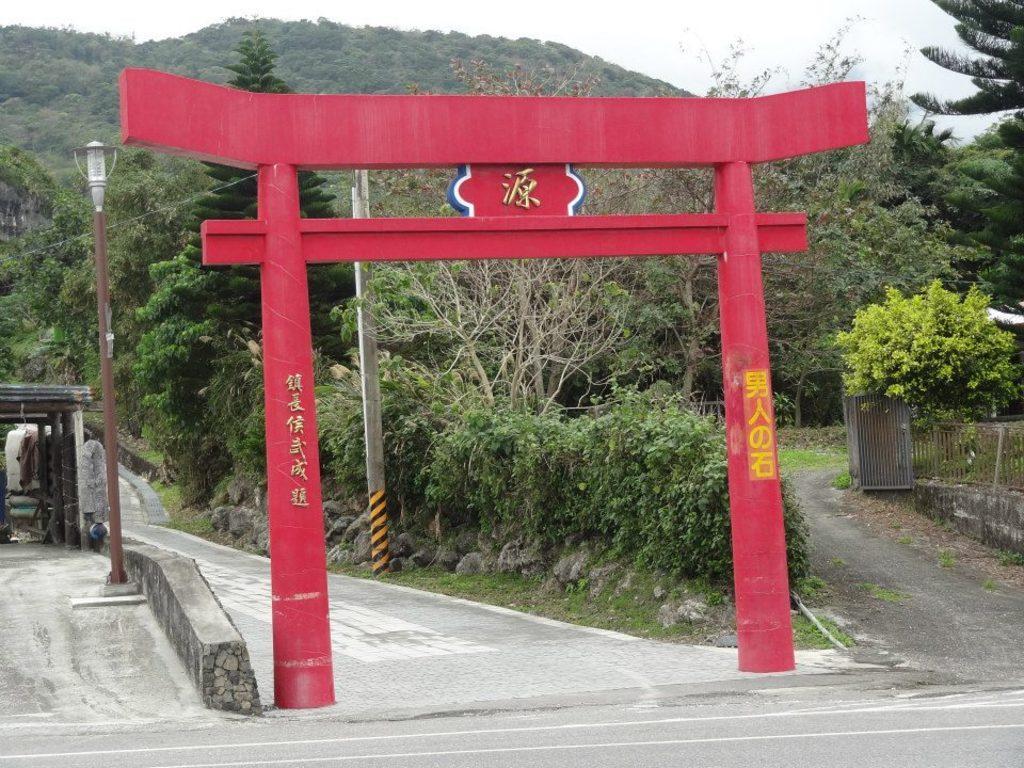Describe this image in one or two sentences. In this picture I can see the arch construction. I can see the road. I can see the trees. I can see the metal grill fence on the right side. I can see the hill. I can see the light pole. 